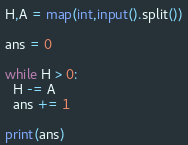<code> <loc_0><loc_0><loc_500><loc_500><_Python_>H,A = map(int,input().split())

ans = 0

while H > 0:
  H -= A
  ans += 1

print(ans)
</code> 